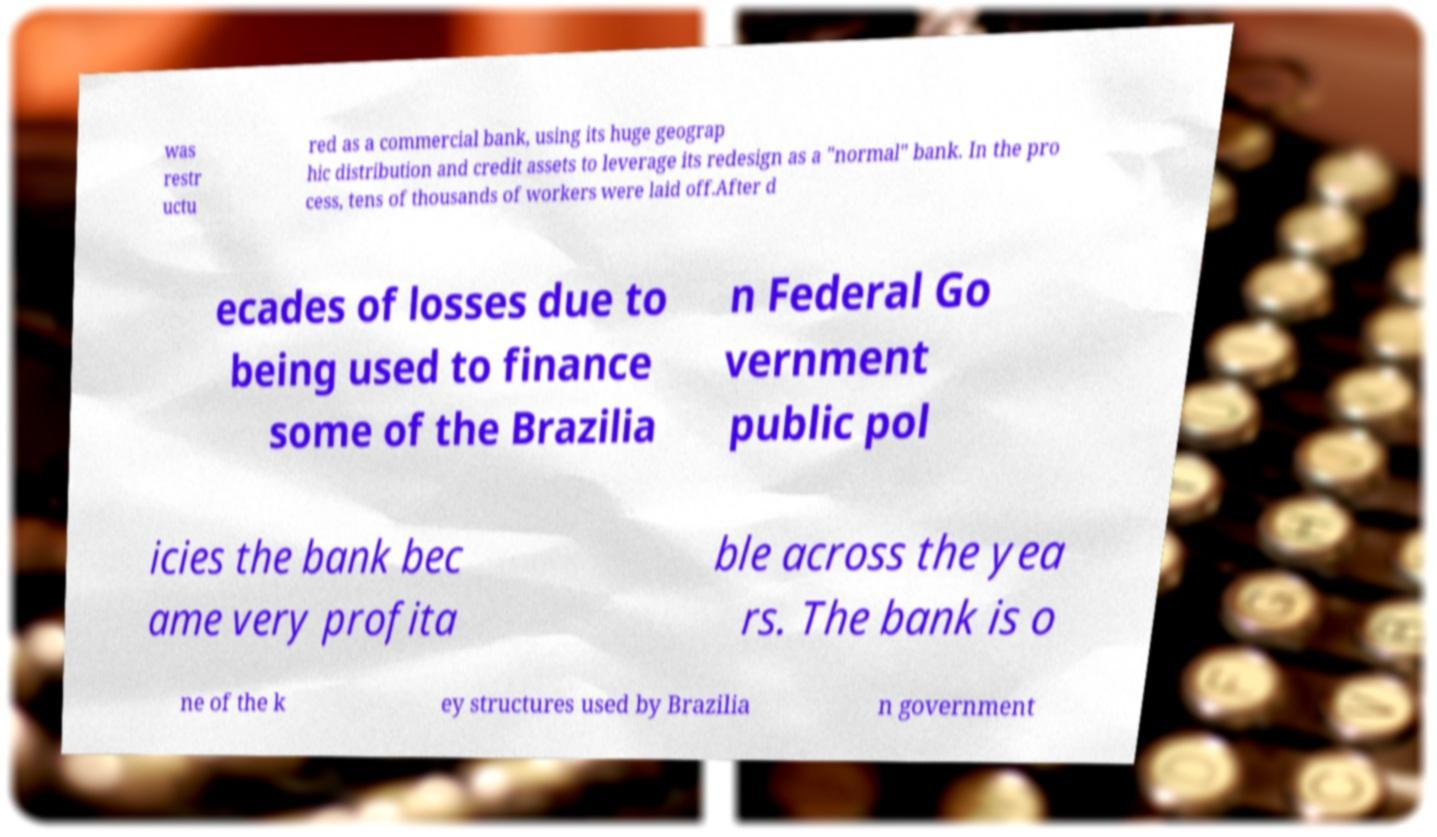There's text embedded in this image that I need extracted. Can you transcribe it verbatim? was restr uctu red as a commercial bank, using its huge geograp hic distribution and credit assets to leverage its redesign as a "normal" bank. In the pro cess, tens of thousands of workers were laid off.After d ecades of losses due to being used to finance some of the Brazilia n Federal Go vernment public pol icies the bank bec ame very profita ble across the yea rs. The bank is o ne of the k ey structures used by Brazilia n government 